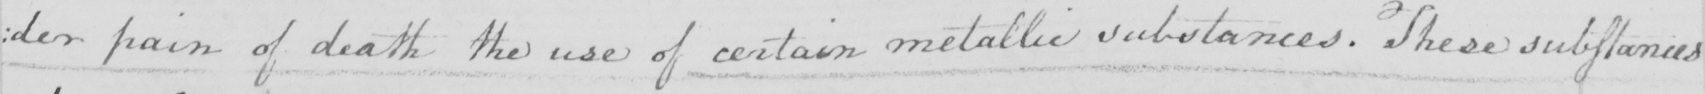Transcribe the text shown in this historical manuscript line. : der pain of death the use of certain metallic substances . These substances 